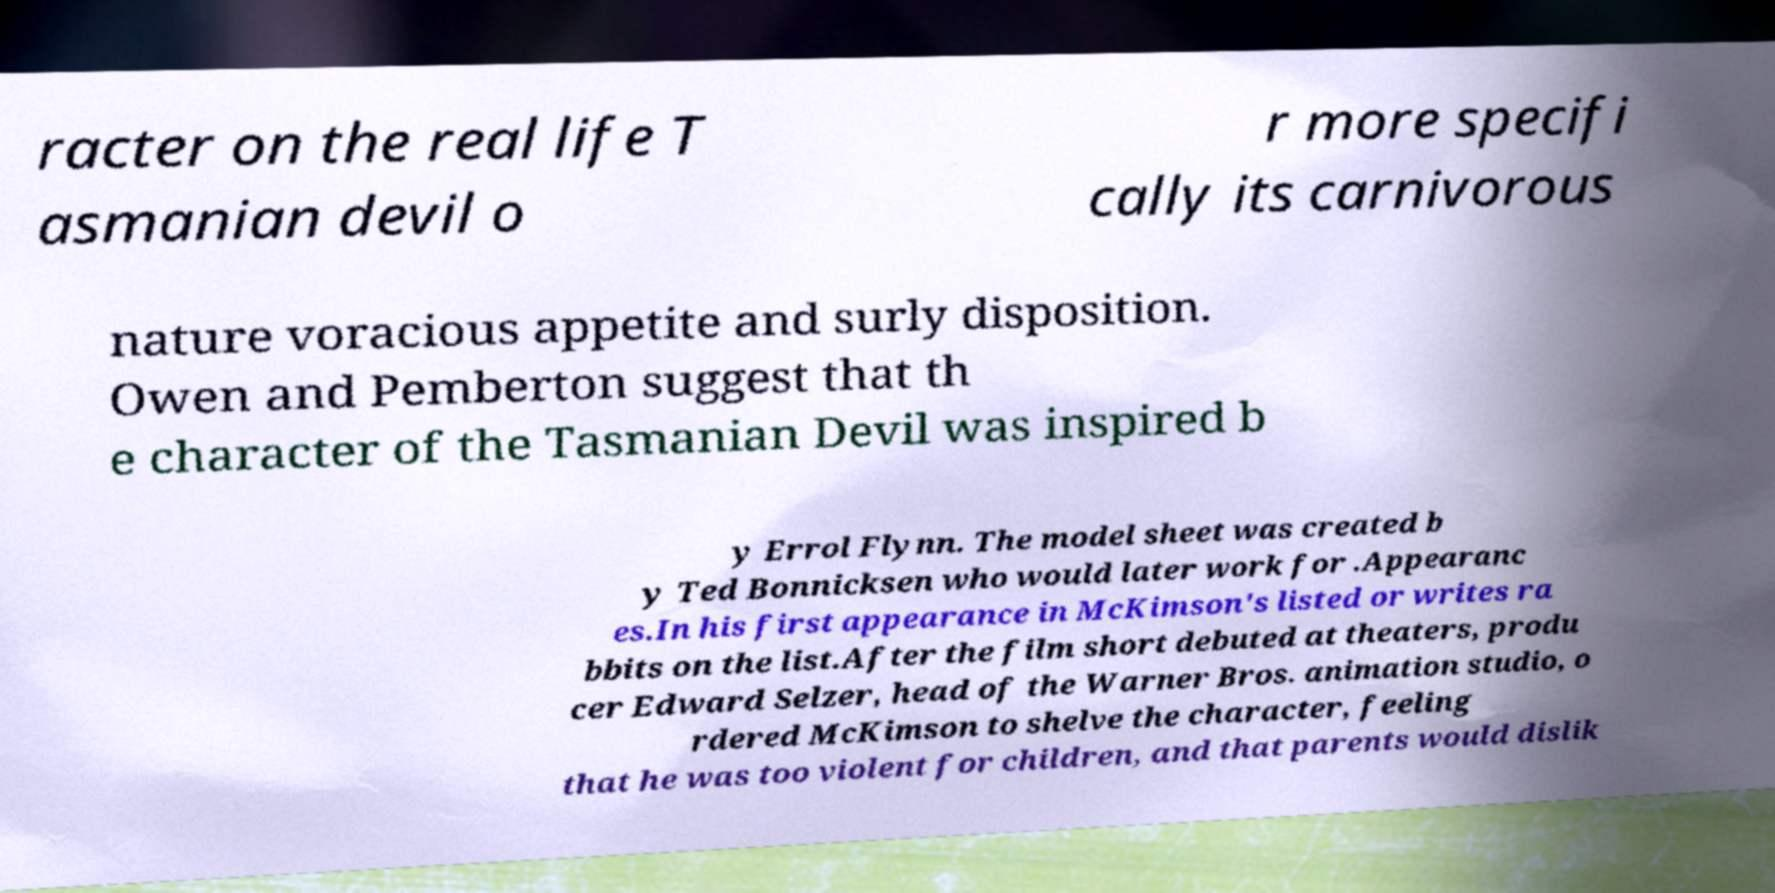Could you extract and type out the text from this image? racter on the real life T asmanian devil o r more specifi cally its carnivorous nature voracious appetite and surly disposition. Owen and Pemberton suggest that th e character of the Tasmanian Devil was inspired b y Errol Flynn. The model sheet was created b y Ted Bonnicksen who would later work for .Appearanc es.In his first appearance in McKimson's listed or writes ra bbits on the list.After the film short debuted at theaters, produ cer Edward Selzer, head of the Warner Bros. animation studio, o rdered McKimson to shelve the character, feeling that he was too violent for children, and that parents would dislik 